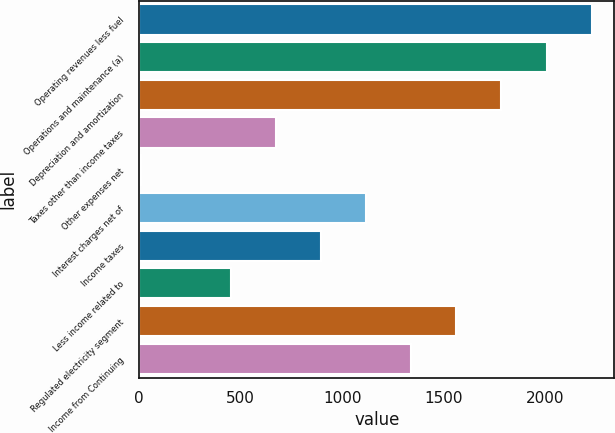Convert chart to OTSL. <chart><loc_0><loc_0><loc_500><loc_500><bar_chart><fcel>Operating revenues less fuel<fcel>Operations and maintenance (a)<fcel>Depreciation and amortization<fcel>Taxes other than income taxes<fcel>Other expenses net<fcel>Interest charges net of<fcel>Income taxes<fcel>Less income related to<fcel>Regulated electricity segment<fcel>Income from Continuing<nl><fcel>2228<fcel>2006<fcel>1784<fcel>674<fcel>8<fcel>1118<fcel>896<fcel>452<fcel>1562<fcel>1340<nl></chart> 